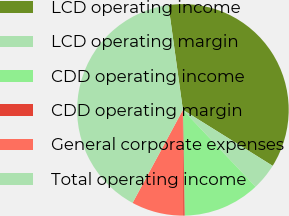Convert chart to OTSL. <chart><loc_0><loc_0><loc_500><loc_500><pie_chart><fcel>LCD operating income<fcel>LCD operating margin<fcel>CDD operating income<fcel>CDD operating margin<fcel>General corporate expenses<fcel>Total operating income<nl><fcel>36.06%<fcel>4.08%<fcel>11.79%<fcel>0.22%<fcel>7.93%<fcel>39.92%<nl></chart> 